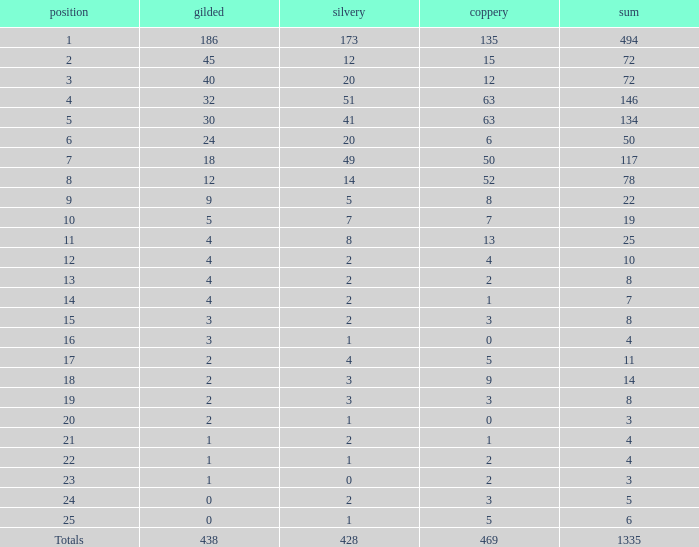What is the number of bronze medals when the total medals were 78 and there were less than 12 golds? None. 